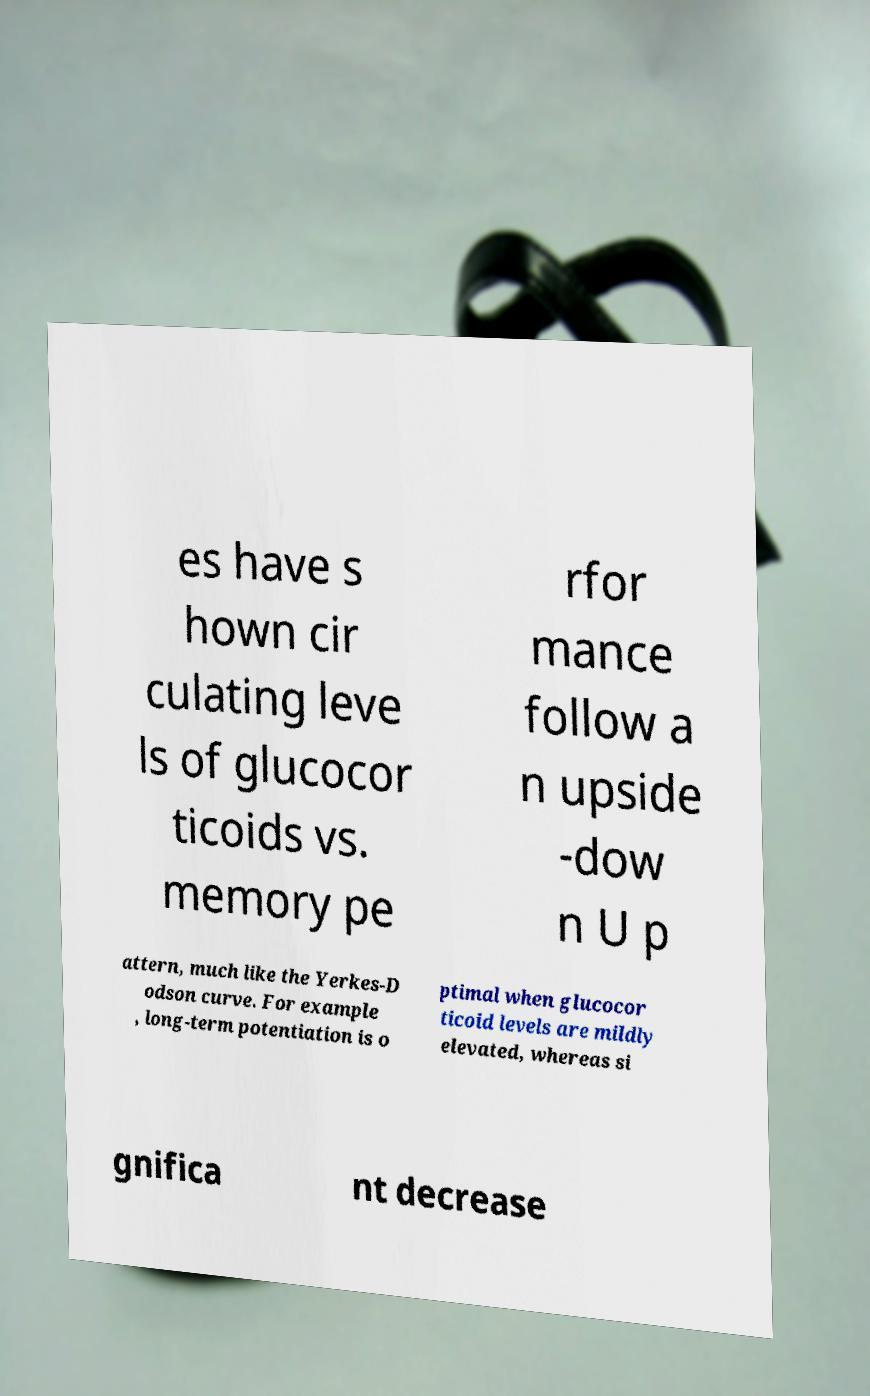Please read and relay the text visible in this image. What does it say? es have s hown cir culating leve ls of glucocor ticoids vs. memory pe rfor mance follow a n upside -dow n U p attern, much like the Yerkes-D odson curve. For example , long-term potentiation is o ptimal when glucocor ticoid levels are mildly elevated, whereas si gnifica nt decrease 